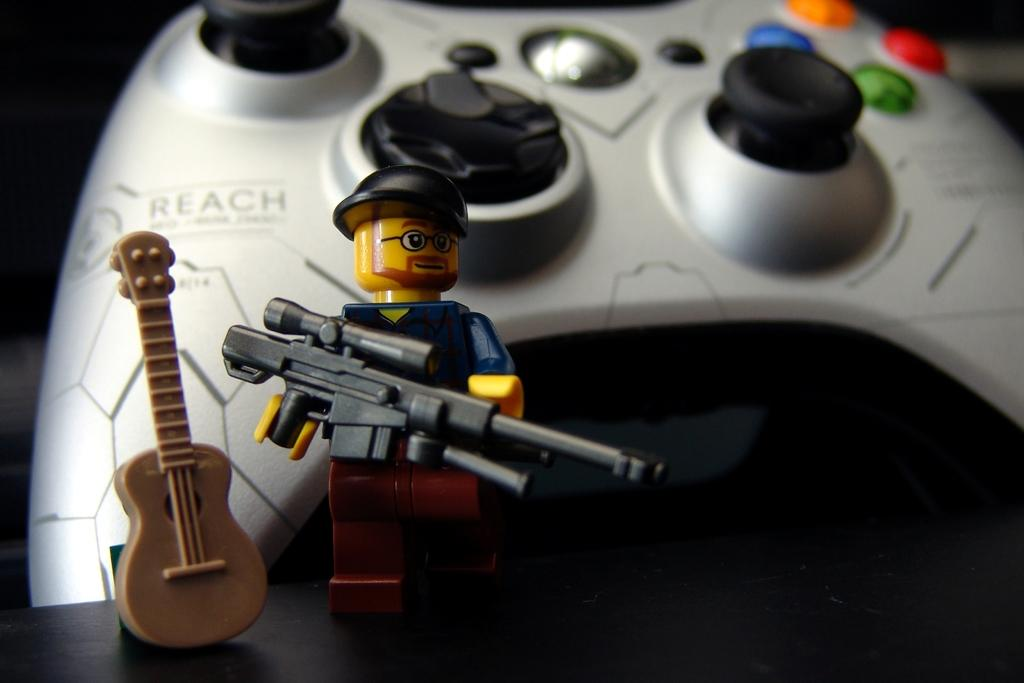What type of toy with a gun and cap is present in the image? There is a toy with a gun and cap in the image. What other toy can be seen in the image? There is a toy guitar in the image. What is located in the background of the image? There is a joystick with buttons in the background of the image. What flavor of vegetable can be seen in the image? There are no vegetables present in the image, and therefore no flavor can be determined. 